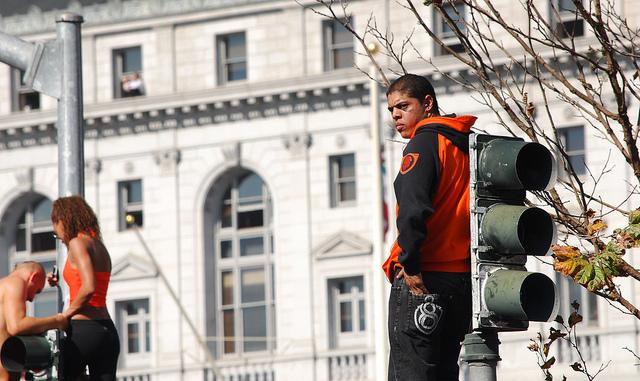Is the man in orange mad or happy?
Short answer required. Mad. Is the traffic light yellow?
Write a very short answer. No. What are the two people wearing?
Give a very brief answer. Orange. 